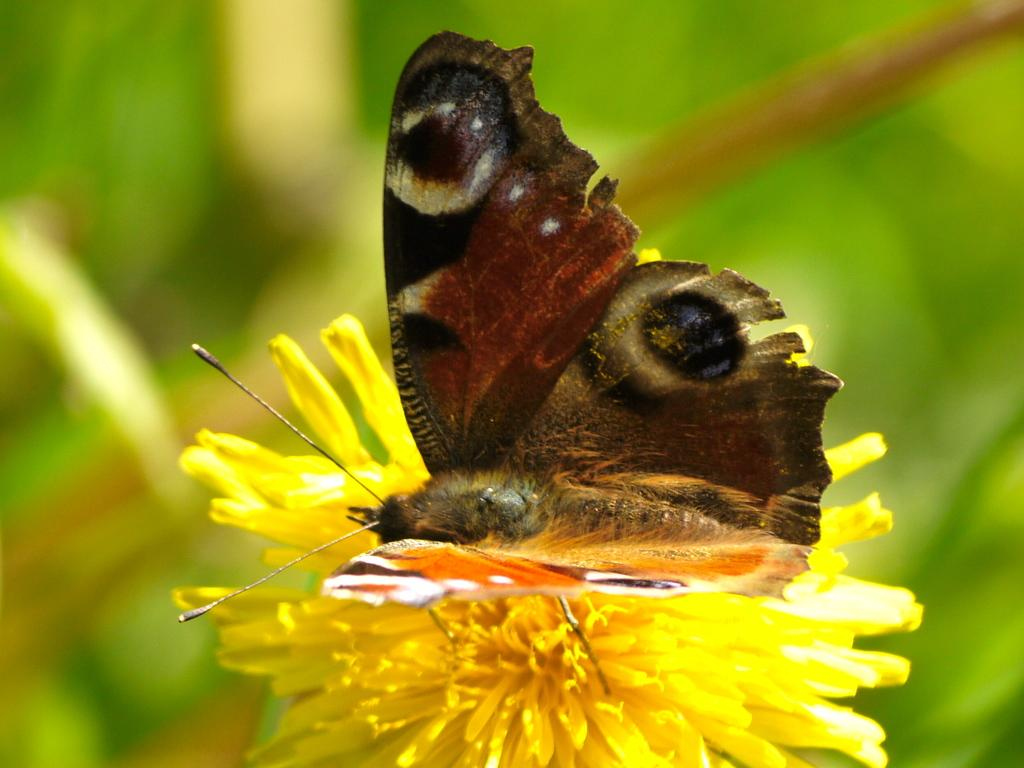What type of insect is present in the image? There is a butterfly in the image. Where is the butterfly located in the image? The butterfly is represented on a flower. What type of lipstick is the butterfly wearing in the image? There is no lipstick or indication of makeup on the butterfly in the image. 